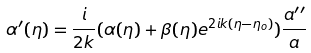Convert formula to latex. <formula><loc_0><loc_0><loc_500><loc_500>\alpha ^ { \prime } ( \eta ) = \frac { i } { 2 k } ( \alpha ( \eta ) + \beta ( \eta ) e ^ { 2 i k ( \eta - \eta _ { o } ) } ) \frac { a ^ { \prime \prime } } { a }</formula> 